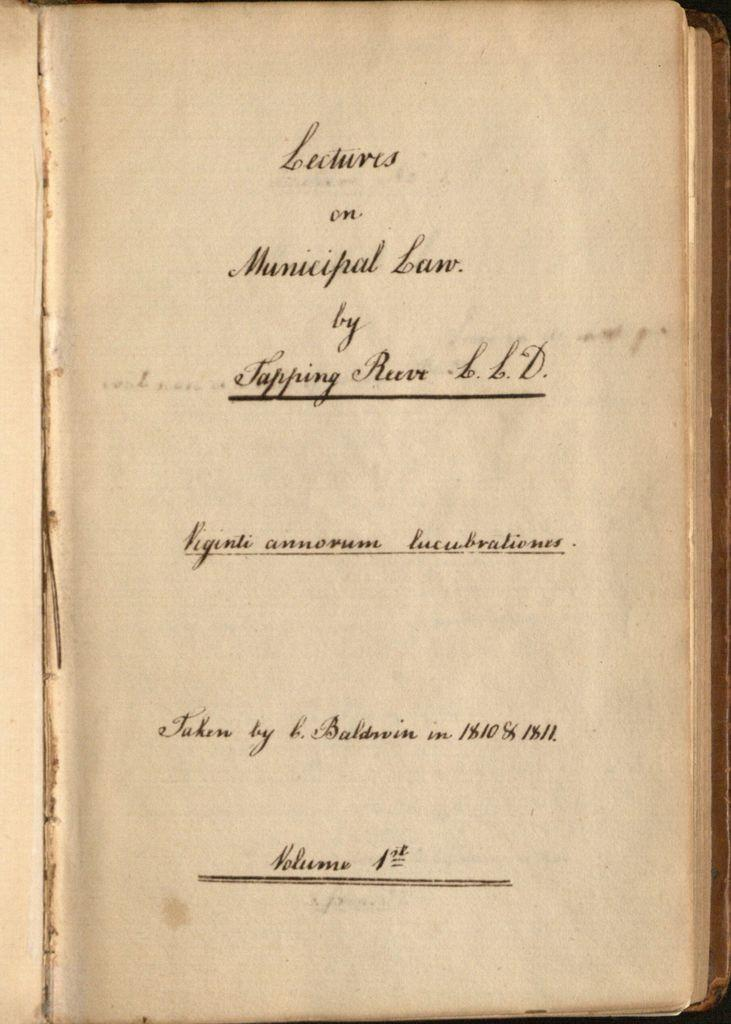Provide a one-sentence caption for the provided image. Lectures on Municipal Law Volume 1 was written by Tapping Reeve. 